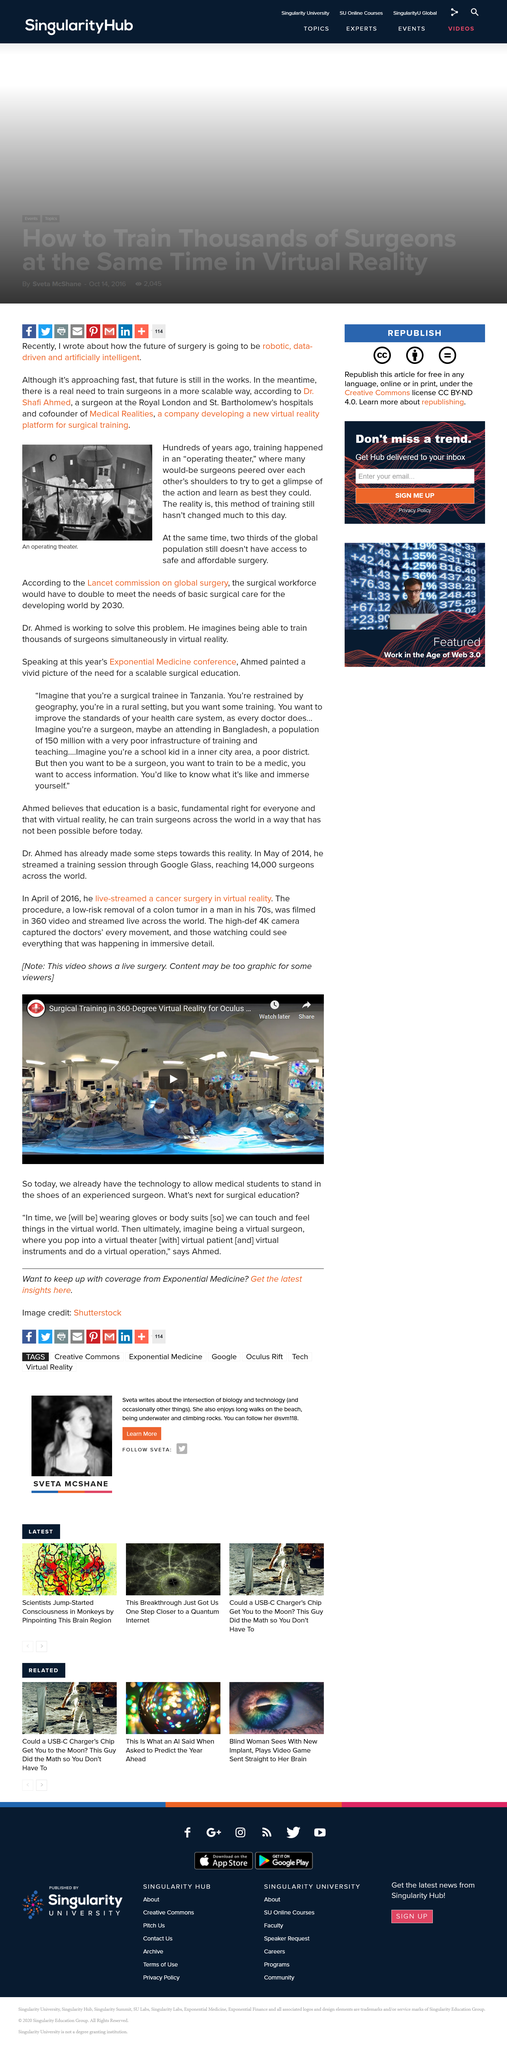Highlight a few significant elements in this photo. The current training for surgeons takes place in operating theatres, and Medical Realities is developing a new virtual reality platform for surgical training that will revolutionize the way surgeons are trained. Dr. Shafi Ahmed is one of the cofounders of Medical Realities. The high-definition 4K camera captured every movement of the doctors in immersive detail, allowing those watching to experience the event in precise and vivid clarity. A colon tumor removal procedure was filmed, which was performed on a man in his 70s and deemed to be low-risk. In April 2016, a live-streamed cancer surgery in virtual reality took place. 